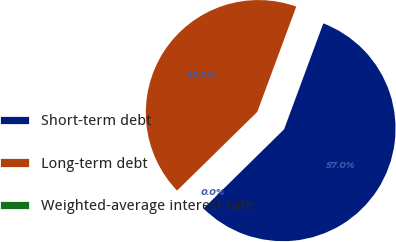<chart> <loc_0><loc_0><loc_500><loc_500><pie_chart><fcel>Short-term debt<fcel>Long-term debt<fcel>Weighted-average interest rate<nl><fcel>56.99%<fcel>42.99%<fcel>0.02%<nl></chart> 